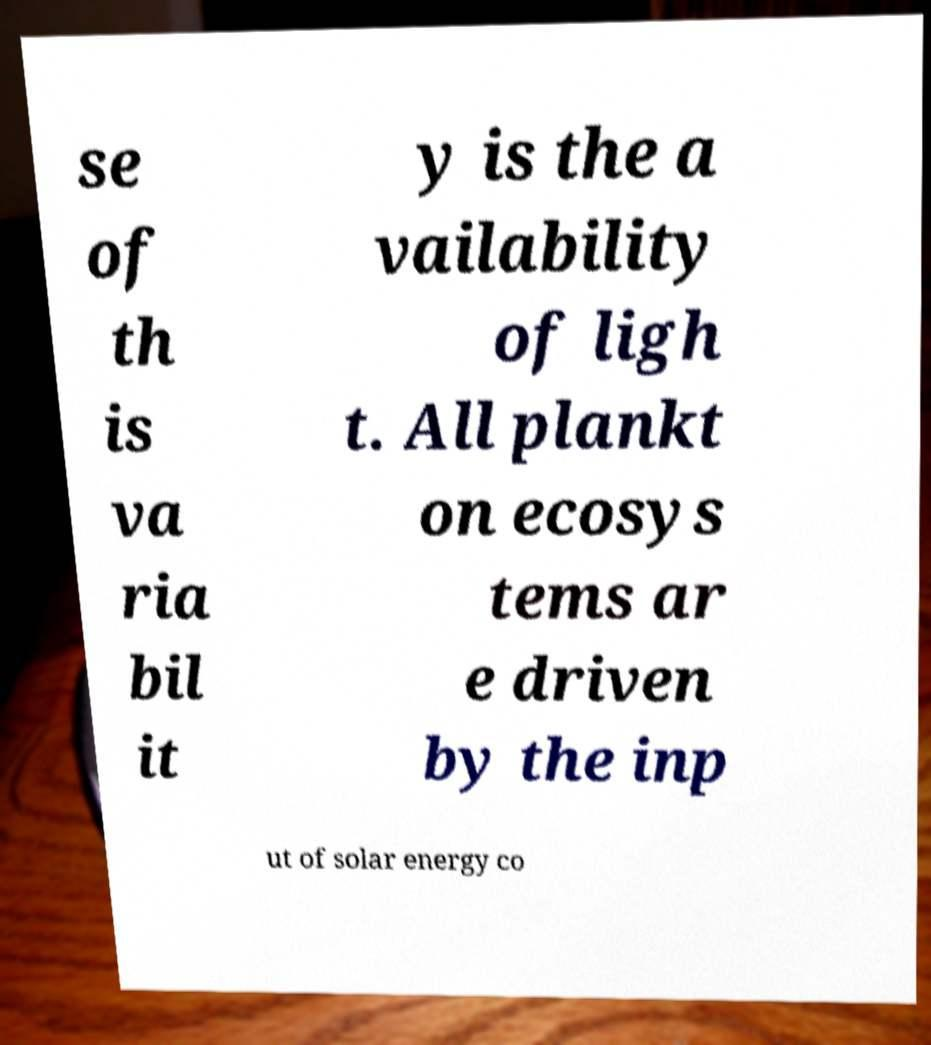There's text embedded in this image that I need extracted. Can you transcribe it verbatim? se of th is va ria bil it y is the a vailability of ligh t. All plankt on ecosys tems ar e driven by the inp ut of solar energy co 